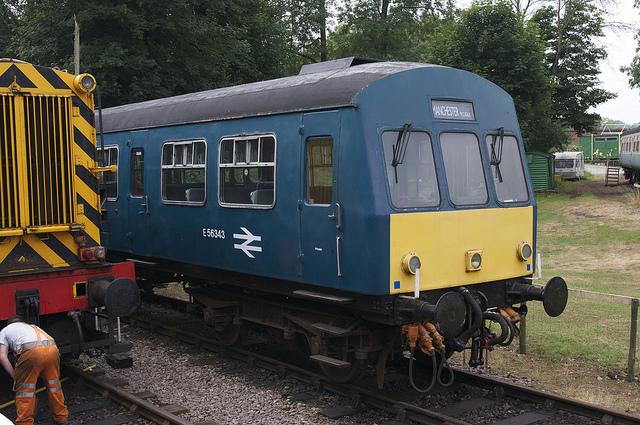Are there trains?
Give a very brief answer. Yes. What is the man doing?
Give a very brief answer. Fixing train. Is the train on the right red?
Concise answer only. No. Why are the people on the edge of the train?
Give a very brief answer. Working. What types of trains are these?
Quick response, please. Passenger. Are the trains attached to each other?
Answer briefly. No. 